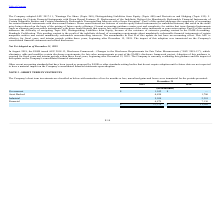From Finjan Holding's financial document, What are the respective values of the company's asset-backed short term investments in 2018 and 2019 respectively? The document shows two values: 1,786 and 4,854 (in thousands). From the document: "Asset Backed 4,854 1,786 Asset Backed 4,854 1,786..." Also, What are the respective values of the company's industrial short term investments in 2018 and 2019 respectively? The document shows two values: 2,381 and 5,034 (in thousands). From the document: "Industrial 5,034 2,381 Industrial 5,034 2,381..." Also, What are the respective values of the company's financial short term investments in 2018 and 2019 respectively? The document shows two values: 7,136 and 6,879 (in thousands). From the document: "Financial 6,879 7,136 Financial 6,879 7,136..." Also, can you calculate: What is the percentage change in the company's asset-backed short term investments between 2018 and 2019? To answer this question, I need to perform calculations using the financial data. The calculation is: (4,854 - 1,786)/1,786 , which equals 171.78 (percentage). This is based on the information: "Asset Backed 4,854 1,786 Asset Backed 4,854 1,786..." The key data points involved are: 1,786, 4,854. Also, can you calculate: What is the percentage change in the company's industrial short term investments between 2018 and 2019? To answer this question, I need to perform calculations using the financial data. The calculation is: (5,034-2,381)/2,381 , which equals 111.42 (percentage). This is based on the information: "Industrial 5,034 2,381 Industrial 5,034 2,381..." The key data points involved are: 2,381, 5,034. Also, can you calculate: What is the percentage change in the company's financial short term investments between 2018 and 2019? To answer this question, I need to perform calculations using the financial data. The calculation is: (6,879 - 7,136)/7,136 , which equals -3.6 (percentage). This is based on the information: "Financial 6,879 7,136 Financial 6,879 7,136..." The key data points involved are: 6,879, 7,136. 